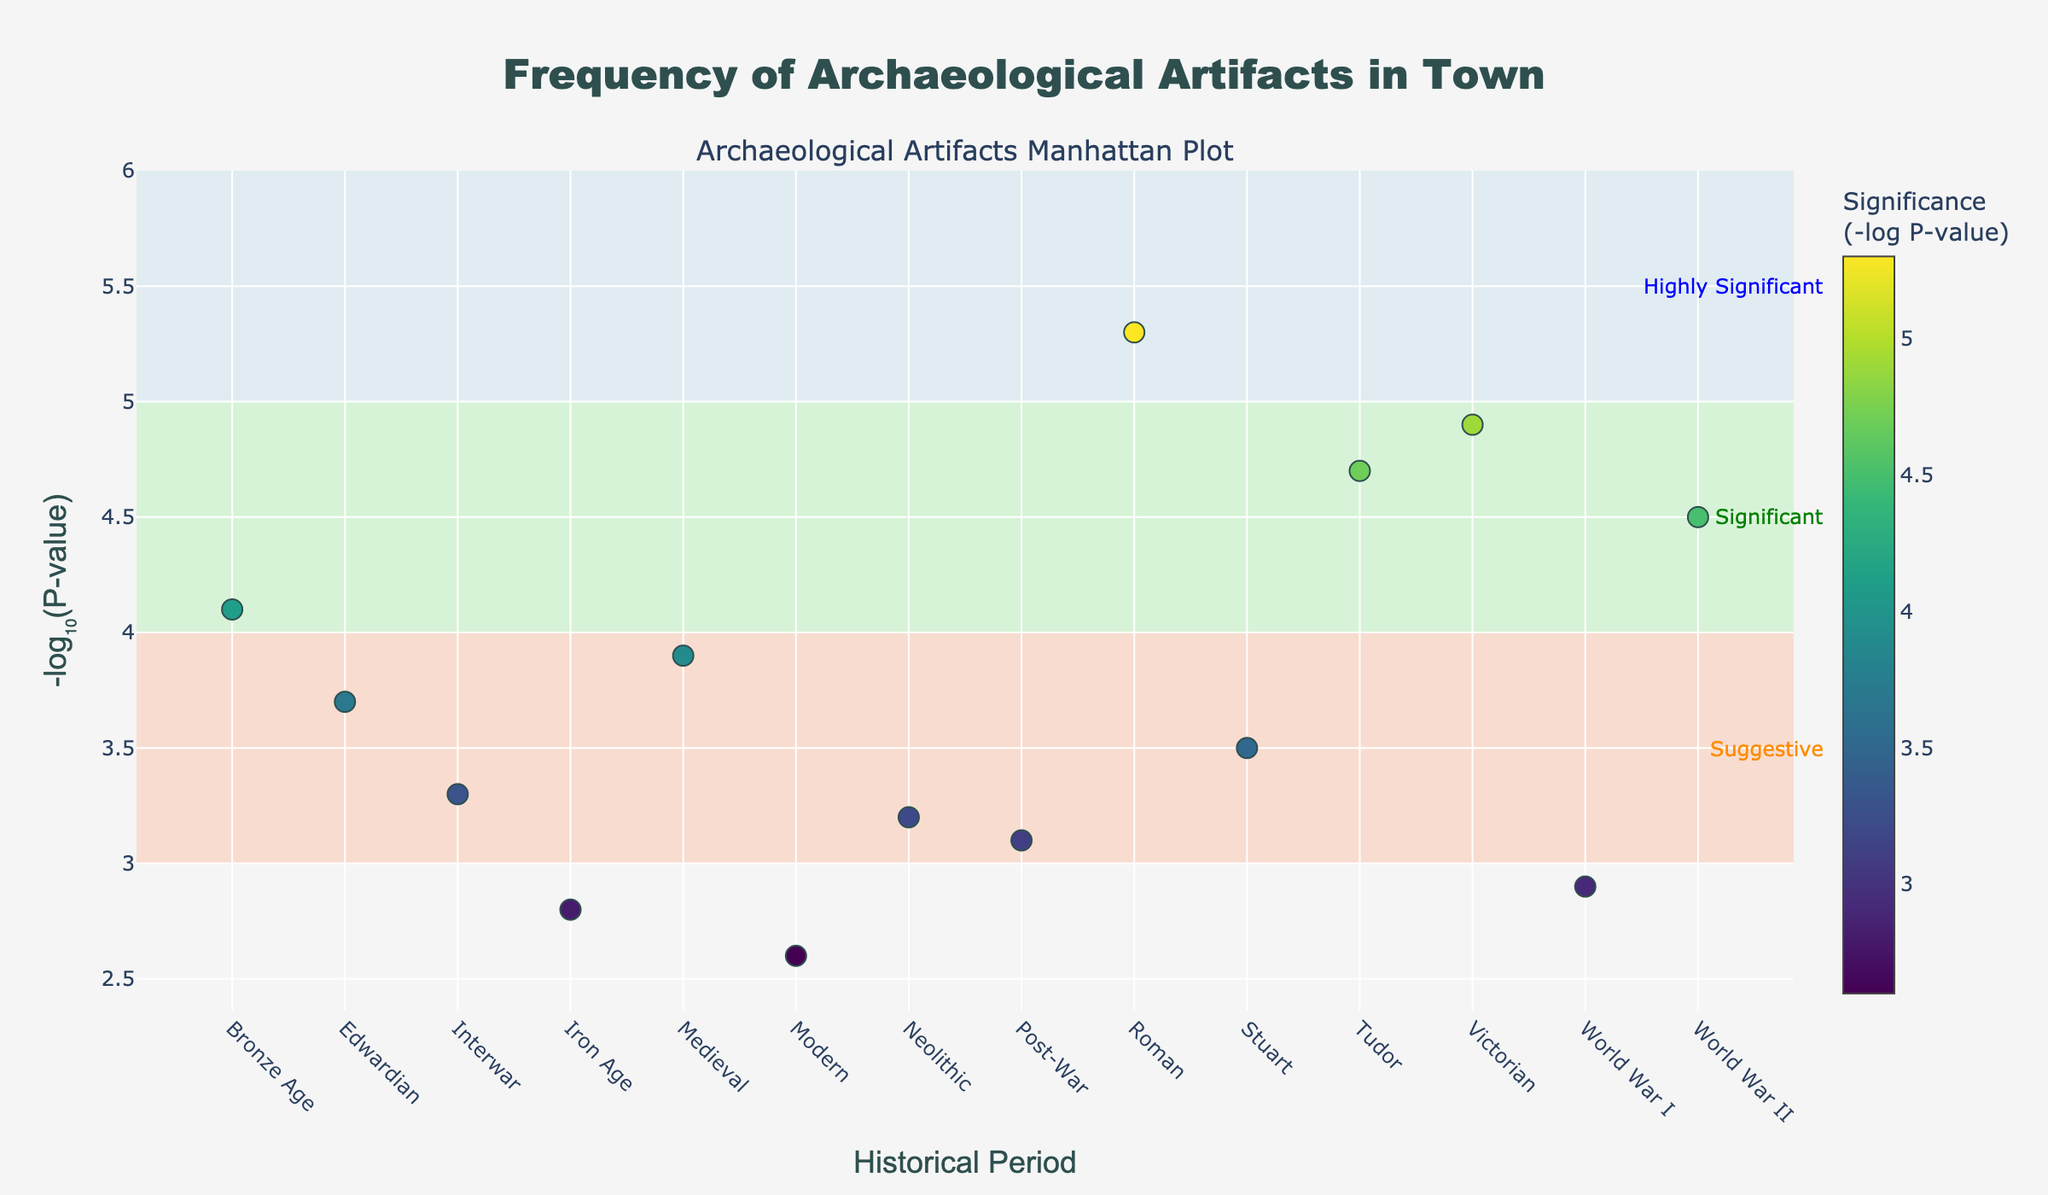How many historical periods are represented in the plot? Count the number of distinct periods on the x-axis.
Answer: 14 Which excavation site has the highest NegativeLogPValue? Identify the data point with the highest y-value.
Answer: Old Mill What is the historical period of the Police Station site? Hover over the Police Station data point to see the period.
Answer: World War II How many sites have a NegativeLogPValue greater than 4? Count the number of data points with a y-value greater than 4.
Answer: 6 Which site in the Medieval period and does it have a high or low significance level? Find the data point labeled Medieval and check its position against the significance levels (rectangles).
Answer: Central Library, Suggestive What is the difference in NegativeLogPValue between the site in the Roman period and the Modern period? Subtract the y-value of the Modern period (Shopping Mall) from the Roman period (Old Mill). 5.3 - 2.6
Answer: 2.7 Which periods have artifacts with similar significance levels (within 0.1 of each other), and what are the neighboring sites for these values? Compare the y-values and identify periods with values within 0.1 difference.
Answer: Medieval (3.9) and Edwardian (3.7); Tudor (4.7) and Victorian (4.9) Which significance level is highlighted by the LightBlue rectangle, and which sites fall into this category? The LightBlue rectangle represents significance levels between 5 and 6. Find data points within this y-value range.
Answer: Highly Significant, Old Mill How are the significance levels indicated in this plot? Note the different colored rectangles and associated annotations explaining the significance levels.
Answer: Colored rectangles: LightSalmon for Suggestive, LightGreen for Significant, LightBlue for Highly Significant What is the total number of excavation sites with a NegativeLogPValue of less than 3? Count the data points with a y-value less than 3.
Answer: 3 